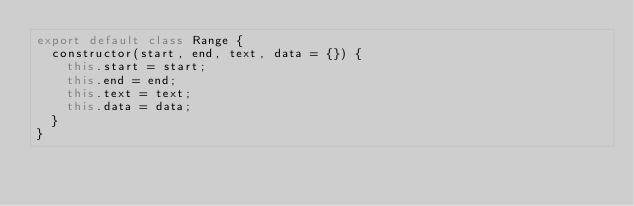<code> <loc_0><loc_0><loc_500><loc_500><_JavaScript_>export default class Range {
  constructor(start, end, text, data = {}) {
    this.start = start;
    this.end = end;
    this.text = text;
    this.data = data;
  }
}
</code> 